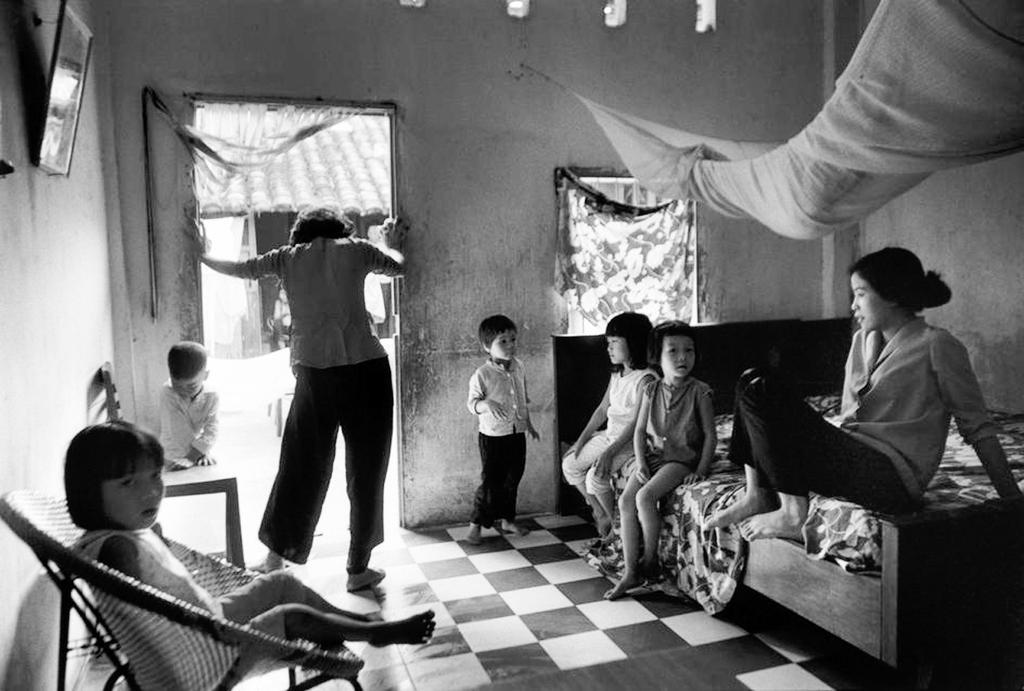Please provide a concise description of this image. This is a black and white image, in this image there are some persons and some children. On the right side there is one bed, on the bed there are some persons sitting. On the left side there is a chairs, on the chairs there are some children sitting. At the bottom there is floor and on the left side there is one photo frame on the wall, on the right side there is one cloth, curtain and a window. And in the background there are some houses. 